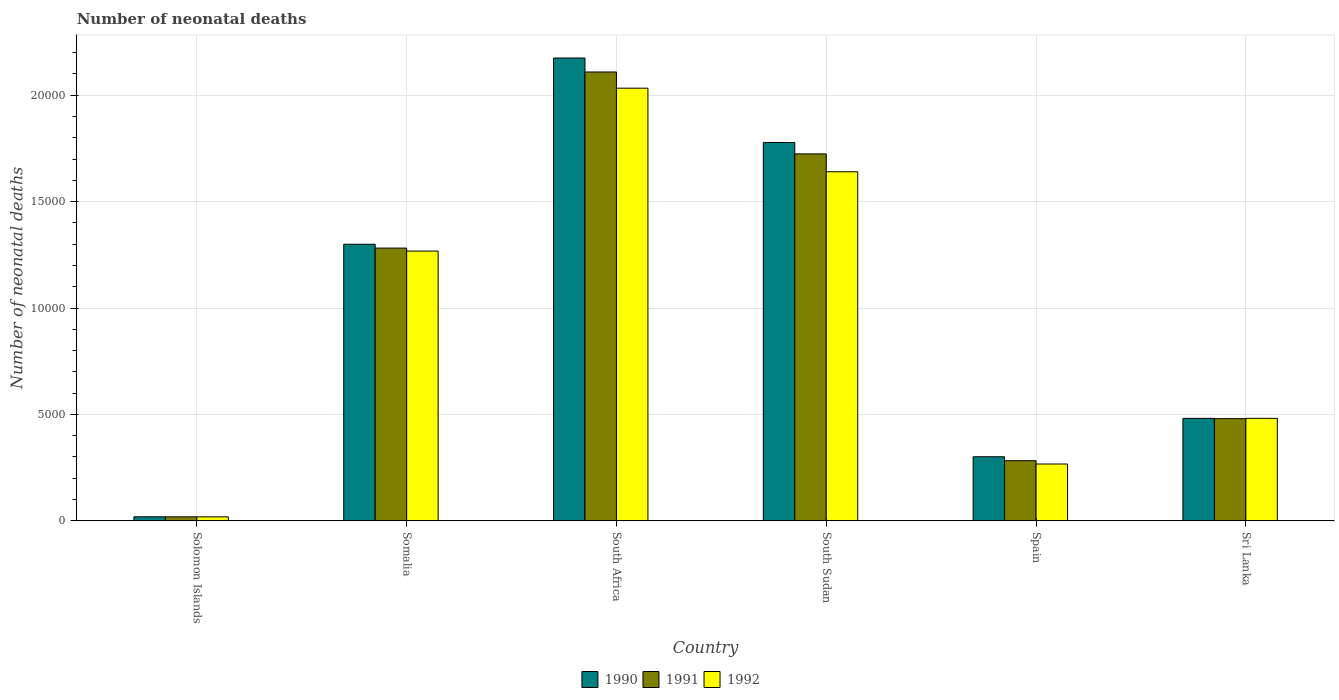How many different coloured bars are there?
Your answer should be very brief. 3. Are the number of bars per tick equal to the number of legend labels?
Ensure brevity in your answer.  Yes. What is the label of the 2nd group of bars from the left?
Provide a succinct answer. Somalia. What is the number of neonatal deaths in in 1990 in South Sudan?
Your response must be concise. 1.78e+04. Across all countries, what is the maximum number of neonatal deaths in in 1991?
Provide a succinct answer. 2.11e+04. Across all countries, what is the minimum number of neonatal deaths in in 1991?
Offer a terse response. 188. In which country was the number of neonatal deaths in in 1991 maximum?
Give a very brief answer. South Africa. In which country was the number of neonatal deaths in in 1992 minimum?
Ensure brevity in your answer.  Solomon Islands. What is the total number of neonatal deaths in in 1991 in the graph?
Provide a short and direct response. 5.90e+04. What is the difference between the number of neonatal deaths in in 1991 in South Africa and that in Spain?
Your answer should be compact. 1.83e+04. What is the difference between the number of neonatal deaths in in 1991 in Spain and the number of neonatal deaths in in 1990 in Somalia?
Offer a terse response. -1.02e+04. What is the average number of neonatal deaths in in 1991 per country?
Ensure brevity in your answer.  9826.5. What is the difference between the number of neonatal deaths in of/in 1992 and number of neonatal deaths in of/in 1990 in South Africa?
Provide a short and direct response. -1417. In how many countries, is the number of neonatal deaths in in 1991 greater than 3000?
Your response must be concise. 4. What is the ratio of the number of neonatal deaths in in 1990 in South Sudan to that in Spain?
Your response must be concise. 5.91. Is the number of neonatal deaths in in 1990 in Somalia less than that in South Sudan?
Your answer should be compact. Yes. What is the difference between the highest and the second highest number of neonatal deaths in in 1992?
Make the answer very short. 7654. What is the difference between the highest and the lowest number of neonatal deaths in in 1990?
Ensure brevity in your answer.  2.16e+04. In how many countries, is the number of neonatal deaths in in 1990 greater than the average number of neonatal deaths in in 1990 taken over all countries?
Keep it short and to the point. 3. Is the sum of the number of neonatal deaths in in 1992 in Solomon Islands and South Sudan greater than the maximum number of neonatal deaths in in 1991 across all countries?
Keep it short and to the point. No. Are all the bars in the graph horizontal?
Provide a succinct answer. No. Does the graph contain grids?
Provide a succinct answer. Yes. How are the legend labels stacked?
Give a very brief answer. Horizontal. What is the title of the graph?
Give a very brief answer. Number of neonatal deaths. What is the label or title of the X-axis?
Ensure brevity in your answer.  Country. What is the label or title of the Y-axis?
Keep it short and to the point. Number of neonatal deaths. What is the Number of neonatal deaths of 1990 in Solomon Islands?
Offer a terse response. 190. What is the Number of neonatal deaths of 1991 in Solomon Islands?
Offer a terse response. 188. What is the Number of neonatal deaths of 1992 in Solomon Islands?
Your answer should be very brief. 187. What is the Number of neonatal deaths of 1990 in Somalia?
Your answer should be compact. 1.30e+04. What is the Number of neonatal deaths of 1991 in Somalia?
Offer a terse response. 1.28e+04. What is the Number of neonatal deaths in 1992 in Somalia?
Make the answer very short. 1.27e+04. What is the Number of neonatal deaths in 1990 in South Africa?
Provide a succinct answer. 2.17e+04. What is the Number of neonatal deaths in 1991 in South Africa?
Provide a succinct answer. 2.11e+04. What is the Number of neonatal deaths in 1992 in South Africa?
Offer a very short reply. 2.03e+04. What is the Number of neonatal deaths in 1990 in South Sudan?
Ensure brevity in your answer.  1.78e+04. What is the Number of neonatal deaths of 1991 in South Sudan?
Ensure brevity in your answer.  1.72e+04. What is the Number of neonatal deaths of 1992 in South Sudan?
Ensure brevity in your answer.  1.64e+04. What is the Number of neonatal deaths in 1990 in Spain?
Your answer should be compact. 3010. What is the Number of neonatal deaths of 1991 in Spain?
Your answer should be compact. 2825. What is the Number of neonatal deaths in 1992 in Spain?
Offer a very short reply. 2670. What is the Number of neonatal deaths of 1990 in Sri Lanka?
Ensure brevity in your answer.  4814. What is the Number of neonatal deaths in 1991 in Sri Lanka?
Give a very brief answer. 4801. What is the Number of neonatal deaths in 1992 in Sri Lanka?
Your answer should be very brief. 4815. Across all countries, what is the maximum Number of neonatal deaths in 1990?
Offer a terse response. 2.17e+04. Across all countries, what is the maximum Number of neonatal deaths of 1991?
Give a very brief answer. 2.11e+04. Across all countries, what is the maximum Number of neonatal deaths of 1992?
Offer a terse response. 2.03e+04. Across all countries, what is the minimum Number of neonatal deaths of 1990?
Your response must be concise. 190. Across all countries, what is the minimum Number of neonatal deaths in 1991?
Keep it short and to the point. 188. Across all countries, what is the minimum Number of neonatal deaths in 1992?
Make the answer very short. 187. What is the total Number of neonatal deaths of 1990 in the graph?
Your answer should be compact. 6.05e+04. What is the total Number of neonatal deaths in 1991 in the graph?
Provide a succinct answer. 5.90e+04. What is the total Number of neonatal deaths of 1992 in the graph?
Keep it short and to the point. 5.71e+04. What is the difference between the Number of neonatal deaths of 1990 in Solomon Islands and that in Somalia?
Provide a succinct answer. -1.28e+04. What is the difference between the Number of neonatal deaths of 1991 in Solomon Islands and that in Somalia?
Provide a succinct answer. -1.26e+04. What is the difference between the Number of neonatal deaths of 1992 in Solomon Islands and that in Somalia?
Offer a terse response. -1.25e+04. What is the difference between the Number of neonatal deaths of 1990 in Solomon Islands and that in South Africa?
Offer a terse response. -2.16e+04. What is the difference between the Number of neonatal deaths of 1991 in Solomon Islands and that in South Africa?
Give a very brief answer. -2.09e+04. What is the difference between the Number of neonatal deaths in 1992 in Solomon Islands and that in South Africa?
Your answer should be very brief. -2.01e+04. What is the difference between the Number of neonatal deaths in 1990 in Solomon Islands and that in South Sudan?
Provide a short and direct response. -1.76e+04. What is the difference between the Number of neonatal deaths in 1991 in Solomon Islands and that in South Sudan?
Provide a short and direct response. -1.71e+04. What is the difference between the Number of neonatal deaths of 1992 in Solomon Islands and that in South Sudan?
Ensure brevity in your answer.  -1.62e+04. What is the difference between the Number of neonatal deaths in 1990 in Solomon Islands and that in Spain?
Provide a succinct answer. -2820. What is the difference between the Number of neonatal deaths of 1991 in Solomon Islands and that in Spain?
Your answer should be very brief. -2637. What is the difference between the Number of neonatal deaths of 1992 in Solomon Islands and that in Spain?
Offer a very short reply. -2483. What is the difference between the Number of neonatal deaths of 1990 in Solomon Islands and that in Sri Lanka?
Provide a succinct answer. -4624. What is the difference between the Number of neonatal deaths in 1991 in Solomon Islands and that in Sri Lanka?
Keep it short and to the point. -4613. What is the difference between the Number of neonatal deaths in 1992 in Solomon Islands and that in Sri Lanka?
Offer a very short reply. -4628. What is the difference between the Number of neonatal deaths of 1990 in Somalia and that in South Africa?
Offer a very short reply. -8751. What is the difference between the Number of neonatal deaths in 1991 in Somalia and that in South Africa?
Your answer should be very brief. -8274. What is the difference between the Number of neonatal deaths in 1992 in Somalia and that in South Africa?
Your answer should be very brief. -7654. What is the difference between the Number of neonatal deaths in 1990 in Somalia and that in South Sudan?
Provide a succinct answer. -4781. What is the difference between the Number of neonatal deaths of 1991 in Somalia and that in South Sudan?
Your answer should be very brief. -4426. What is the difference between the Number of neonatal deaths in 1992 in Somalia and that in South Sudan?
Your response must be concise. -3726. What is the difference between the Number of neonatal deaths in 1990 in Somalia and that in Spain?
Keep it short and to the point. 9985. What is the difference between the Number of neonatal deaths in 1991 in Somalia and that in Spain?
Your answer should be very brief. 9990. What is the difference between the Number of neonatal deaths of 1992 in Somalia and that in Spain?
Keep it short and to the point. 1.00e+04. What is the difference between the Number of neonatal deaths in 1990 in Somalia and that in Sri Lanka?
Offer a terse response. 8181. What is the difference between the Number of neonatal deaths of 1991 in Somalia and that in Sri Lanka?
Your answer should be compact. 8014. What is the difference between the Number of neonatal deaths in 1992 in Somalia and that in Sri Lanka?
Provide a short and direct response. 7860. What is the difference between the Number of neonatal deaths of 1990 in South Africa and that in South Sudan?
Give a very brief answer. 3970. What is the difference between the Number of neonatal deaths of 1991 in South Africa and that in South Sudan?
Ensure brevity in your answer.  3848. What is the difference between the Number of neonatal deaths of 1992 in South Africa and that in South Sudan?
Provide a short and direct response. 3928. What is the difference between the Number of neonatal deaths of 1990 in South Africa and that in Spain?
Your answer should be compact. 1.87e+04. What is the difference between the Number of neonatal deaths of 1991 in South Africa and that in Spain?
Give a very brief answer. 1.83e+04. What is the difference between the Number of neonatal deaths in 1992 in South Africa and that in Spain?
Provide a succinct answer. 1.77e+04. What is the difference between the Number of neonatal deaths of 1990 in South Africa and that in Sri Lanka?
Provide a succinct answer. 1.69e+04. What is the difference between the Number of neonatal deaths of 1991 in South Africa and that in Sri Lanka?
Make the answer very short. 1.63e+04. What is the difference between the Number of neonatal deaths in 1992 in South Africa and that in Sri Lanka?
Offer a terse response. 1.55e+04. What is the difference between the Number of neonatal deaths of 1990 in South Sudan and that in Spain?
Your answer should be compact. 1.48e+04. What is the difference between the Number of neonatal deaths of 1991 in South Sudan and that in Spain?
Give a very brief answer. 1.44e+04. What is the difference between the Number of neonatal deaths in 1992 in South Sudan and that in Spain?
Offer a terse response. 1.37e+04. What is the difference between the Number of neonatal deaths in 1990 in South Sudan and that in Sri Lanka?
Ensure brevity in your answer.  1.30e+04. What is the difference between the Number of neonatal deaths of 1991 in South Sudan and that in Sri Lanka?
Your answer should be compact. 1.24e+04. What is the difference between the Number of neonatal deaths in 1992 in South Sudan and that in Sri Lanka?
Provide a succinct answer. 1.16e+04. What is the difference between the Number of neonatal deaths of 1990 in Spain and that in Sri Lanka?
Your answer should be compact. -1804. What is the difference between the Number of neonatal deaths of 1991 in Spain and that in Sri Lanka?
Offer a terse response. -1976. What is the difference between the Number of neonatal deaths in 1992 in Spain and that in Sri Lanka?
Your answer should be very brief. -2145. What is the difference between the Number of neonatal deaths in 1990 in Solomon Islands and the Number of neonatal deaths in 1991 in Somalia?
Provide a short and direct response. -1.26e+04. What is the difference between the Number of neonatal deaths of 1990 in Solomon Islands and the Number of neonatal deaths of 1992 in Somalia?
Your answer should be very brief. -1.25e+04. What is the difference between the Number of neonatal deaths in 1991 in Solomon Islands and the Number of neonatal deaths in 1992 in Somalia?
Ensure brevity in your answer.  -1.25e+04. What is the difference between the Number of neonatal deaths of 1990 in Solomon Islands and the Number of neonatal deaths of 1991 in South Africa?
Ensure brevity in your answer.  -2.09e+04. What is the difference between the Number of neonatal deaths of 1990 in Solomon Islands and the Number of neonatal deaths of 1992 in South Africa?
Your answer should be compact. -2.01e+04. What is the difference between the Number of neonatal deaths of 1991 in Solomon Islands and the Number of neonatal deaths of 1992 in South Africa?
Make the answer very short. -2.01e+04. What is the difference between the Number of neonatal deaths in 1990 in Solomon Islands and the Number of neonatal deaths in 1991 in South Sudan?
Your answer should be compact. -1.71e+04. What is the difference between the Number of neonatal deaths of 1990 in Solomon Islands and the Number of neonatal deaths of 1992 in South Sudan?
Your answer should be very brief. -1.62e+04. What is the difference between the Number of neonatal deaths of 1991 in Solomon Islands and the Number of neonatal deaths of 1992 in South Sudan?
Your answer should be compact. -1.62e+04. What is the difference between the Number of neonatal deaths in 1990 in Solomon Islands and the Number of neonatal deaths in 1991 in Spain?
Provide a short and direct response. -2635. What is the difference between the Number of neonatal deaths in 1990 in Solomon Islands and the Number of neonatal deaths in 1992 in Spain?
Keep it short and to the point. -2480. What is the difference between the Number of neonatal deaths of 1991 in Solomon Islands and the Number of neonatal deaths of 1992 in Spain?
Offer a very short reply. -2482. What is the difference between the Number of neonatal deaths of 1990 in Solomon Islands and the Number of neonatal deaths of 1991 in Sri Lanka?
Provide a succinct answer. -4611. What is the difference between the Number of neonatal deaths in 1990 in Solomon Islands and the Number of neonatal deaths in 1992 in Sri Lanka?
Offer a very short reply. -4625. What is the difference between the Number of neonatal deaths in 1991 in Solomon Islands and the Number of neonatal deaths in 1992 in Sri Lanka?
Your answer should be compact. -4627. What is the difference between the Number of neonatal deaths in 1990 in Somalia and the Number of neonatal deaths in 1991 in South Africa?
Your answer should be very brief. -8094. What is the difference between the Number of neonatal deaths in 1990 in Somalia and the Number of neonatal deaths in 1992 in South Africa?
Keep it short and to the point. -7334. What is the difference between the Number of neonatal deaths in 1991 in Somalia and the Number of neonatal deaths in 1992 in South Africa?
Provide a short and direct response. -7514. What is the difference between the Number of neonatal deaths of 1990 in Somalia and the Number of neonatal deaths of 1991 in South Sudan?
Make the answer very short. -4246. What is the difference between the Number of neonatal deaths of 1990 in Somalia and the Number of neonatal deaths of 1992 in South Sudan?
Make the answer very short. -3406. What is the difference between the Number of neonatal deaths in 1991 in Somalia and the Number of neonatal deaths in 1992 in South Sudan?
Provide a succinct answer. -3586. What is the difference between the Number of neonatal deaths in 1990 in Somalia and the Number of neonatal deaths in 1991 in Spain?
Offer a terse response. 1.02e+04. What is the difference between the Number of neonatal deaths in 1990 in Somalia and the Number of neonatal deaths in 1992 in Spain?
Make the answer very short. 1.03e+04. What is the difference between the Number of neonatal deaths in 1991 in Somalia and the Number of neonatal deaths in 1992 in Spain?
Provide a short and direct response. 1.01e+04. What is the difference between the Number of neonatal deaths of 1990 in Somalia and the Number of neonatal deaths of 1991 in Sri Lanka?
Offer a terse response. 8194. What is the difference between the Number of neonatal deaths of 1990 in Somalia and the Number of neonatal deaths of 1992 in Sri Lanka?
Your response must be concise. 8180. What is the difference between the Number of neonatal deaths of 1991 in Somalia and the Number of neonatal deaths of 1992 in Sri Lanka?
Give a very brief answer. 8000. What is the difference between the Number of neonatal deaths of 1990 in South Africa and the Number of neonatal deaths of 1991 in South Sudan?
Ensure brevity in your answer.  4505. What is the difference between the Number of neonatal deaths in 1990 in South Africa and the Number of neonatal deaths in 1992 in South Sudan?
Provide a short and direct response. 5345. What is the difference between the Number of neonatal deaths of 1991 in South Africa and the Number of neonatal deaths of 1992 in South Sudan?
Give a very brief answer. 4688. What is the difference between the Number of neonatal deaths of 1990 in South Africa and the Number of neonatal deaths of 1991 in Spain?
Make the answer very short. 1.89e+04. What is the difference between the Number of neonatal deaths in 1990 in South Africa and the Number of neonatal deaths in 1992 in Spain?
Your answer should be very brief. 1.91e+04. What is the difference between the Number of neonatal deaths in 1991 in South Africa and the Number of neonatal deaths in 1992 in Spain?
Offer a terse response. 1.84e+04. What is the difference between the Number of neonatal deaths in 1990 in South Africa and the Number of neonatal deaths in 1991 in Sri Lanka?
Make the answer very short. 1.69e+04. What is the difference between the Number of neonatal deaths of 1990 in South Africa and the Number of neonatal deaths of 1992 in Sri Lanka?
Your response must be concise. 1.69e+04. What is the difference between the Number of neonatal deaths in 1991 in South Africa and the Number of neonatal deaths in 1992 in Sri Lanka?
Your response must be concise. 1.63e+04. What is the difference between the Number of neonatal deaths in 1990 in South Sudan and the Number of neonatal deaths in 1991 in Spain?
Keep it short and to the point. 1.50e+04. What is the difference between the Number of neonatal deaths of 1990 in South Sudan and the Number of neonatal deaths of 1992 in Spain?
Make the answer very short. 1.51e+04. What is the difference between the Number of neonatal deaths of 1991 in South Sudan and the Number of neonatal deaths of 1992 in Spain?
Make the answer very short. 1.46e+04. What is the difference between the Number of neonatal deaths in 1990 in South Sudan and the Number of neonatal deaths in 1991 in Sri Lanka?
Your answer should be very brief. 1.30e+04. What is the difference between the Number of neonatal deaths of 1990 in South Sudan and the Number of neonatal deaths of 1992 in Sri Lanka?
Offer a very short reply. 1.30e+04. What is the difference between the Number of neonatal deaths of 1991 in South Sudan and the Number of neonatal deaths of 1992 in Sri Lanka?
Give a very brief answer. 1.24e+04. What is the difference between the Number of neonatal deaths in 1990 in Spain and the Number of neonatal deaths in 1991 in Sri Lanka?
Make the answer very short. -1791. What is the difference between the Number of neonatal deaths of 1990 in Spain and the Number of neonatal deaths of 1992 in Sri Lanka?
Provide a short and direct response. -1805. What is the difference between the Number of neonatal deaths in 1991 in Spain and the Number of neonatal deaths in 1992 in Sri Lanka?
Offer a terse response. -1990. What is the average Number of neonatal deaths in 1990 per country?
Your answer should be compact. 1.01e+04. What is the average Number of neonatal deaths of 1991 per country?
Give a very brief answer. 9826.5. What is the average Number of neonatal deaths in 1992 per country?
Your answer should be very brief. 9512.83. What is the difference between the Number of neonatal deaths of 1990 and Number of neonatal deaths of 1991 in Solomon Islands?
Keep it short and to the point. 2. What is the difference between the Number of neonatal deaths of 1990 and Number of neonatal deaths of 1991 in Somalia?
Your answer should be compact. 180. What is the difference between the Number of neonatal deaths in 1990 and Number of neonatal deaths in 1992 in Somalia?
Make the answer very short. 320. What is the difference between the Number of neonatal deaths of 1991 and Number of neonatal deaths of 1992 in Somalia?
Provide a short and direct response. 140. What is the difference between the Number of neonatal deaths of 1990 and Number of neonatal deaths of 1991 in South Africa?
Provide a succinct answer. 657. What is the difference between the Number of neonatal deaths in 1990 and Number of neonatal deaths in 1992 in South Africa?
Your response must be concise. 1417. What is the difference between the Number of neonatal deaths of 1991 and Number of neonatal deaths of 1992 in South Africa?
Provide a succinct answer. 760. What is the difference between the Number of neonatal deaths in 1990 and Number of neonatal deaths in 1991 in South Sudan?
Make the answer very short. 535. What is the difference between the Number of neonatal deaths of 1990 and Number of neonatal deaths of 1992 in South Sudan?
Your answer should be very brief. 1375. What is the difference between the Number of neonatal deaths of 1991 and Number of neonatal deaths of 1992 in South Sudan?
Your response must be concise. 840. What is the difference between the Number of neonatal deaths in 1990 and Number of neonatal deaths in 1991 in Spain?
Give a very brief answer. 185. What is the difference between the Number of neonatal deaths in 1990 and Number of neonatal deaths in 1992 in Spain?
Provide a succinct answer. 340. What is the difference between the Number of neonatal deaths in 1991 and Number of neonatal deaths in 1992 in Spain?
Make the answer very short. 155. What is the difference between the Number of neonatal deaths of 1990 and Number of neonatal deaths of 1991 in Sri Lanka?
Make the answer very short. 13. What is the difference between the Number of neonatal deaths in 1990 and Number of neonatal deaths in 1992 in Sri Lanka?
Keep it short and to the point. -1. What is the difference between the Number of neonatal deaths of 1991 and Number of neonatal deaths of 1992 in Sri Lanka?
Make the answer very short. -14. What is the ratio of the Number of neonatal deaths in 1990 in Solomon Islands to that in Somalia?
Provide a succinct answer. 0.01. What is the ratio of the Number of neonatal deaths of 1991 in Solomon Islands to that in Somalia?
Ensure brevity in your answer.  0.01. What is the ratio of the Number of neonatal deaths of 1992 in Solomon Islands to that in Somalia?
Offer a terse response. 0.01. What is the ratio of the Number of neonatal deaths in 1990 in Solomon Islands to that in South Africa?
Ensure brevity in your answer.  0.01. What is the ratio of the Number of neonatal deaths in 1991 in Solomon Islands to that in South Africa?
Offer a terse response. 0.01. What is the ratio of the Number of neonatal deaths of 1992 in Solomon Islands to that in South Africa?
Provide a succinct answer. 0.01. What is the ratio of the Number of neonatal deaths of 1990 in Solomon Islands to that in South Sudan?
Offer a terse response. 0.01. What is the ratio of the Number of neonatal deaths in 1991 in Solomon Islands to that in South Sudan?
Keep it short and to the point. 0.01. What is the ratio of the Number of neonatal deaths of 1992 in Solomon Islands to that in South Sudan?
Offer a terse response. 0.01. What is the ratio of the Number of neonatal deaths in 1990 in Solomon Islands to that in Spain?
Your response must be concise. 0.06. What is the ratio of the Number of neonatal deaths in 1991 in Solomon Islands to that in Spain?
Offer a very short reply. 0.07. What is the ratio of the Number of neonatal deaths of 1992 in Solomon Islands to that in Spain?
Provide a succinct answer. 0.07. What is the ratio of the Number of neonatal deaths of 1990 in Solomon Islands to that in Sri Lanka?
Ensure brevity in your answer.  0.04. What is the ratio of the Number of neonatal deaths in 1991 in Solomon Islands to that in Sri Lanka?
Provide a short and direct response. 0.04. What is the ratio of the Number of neonatal deaths in 1992 in Solomon Islands to that in Sri Lanka?
Offer a very short reply. 0.04. What is the ratio of the Number of neonatal deaths of 1990 in Somalia to that in South Africa?
Offer a very short reply. 0.6. What is the ratio of the Number of neonatal deaths of 1991 in Somalia to that in South Africa?
Make the answer very short. 0.61. What is the ratio of the Number of neonatal deaths of 1992 in Somalia to that in South Africa?
Offer a terse response. 0.62. What is the ratio of the Number of neonatal deaths in 1990 in Somalia to that in South Sudan?
Offer a terse response. 0.73. What is the ratio of the Number of neonatal deaths in 1991 in Somalia to that in South Sudan?
Your answer should be compact. 0.74. What is the ratio of the Number of neonatal deaths of 1992 in Somalia to that in South Sudan?
Provide a succinct answer. 0.77. What is the ratio of the Number of neonatal deaths in 1990 in Somalia to that in Spain?
Keep it short and to the point. 4.32. What is the ratio of the Number of neonatal deaths in 1991 in Somalia to that in Spain?
Ensure brevity in your answer.  4.54. What is the ratio of the Number of neonatal deaths in 1992 in Somalia to that in Spain?
Your answer should be compact. 4.75. What is the ratio of the Number of neonatal deaths of 1990 in Somalia to that in Sri Lanka?
Provide a succinct answer. 2.7. What is the ratio of the Number of neonatal deaths in 1991 in Somalia to that in Sri Lanka?
Provide a short and direct response. 2.67. What is the ratio of the Number of neonatal deaths in 1992 in Somalia to that in Sri Lanka?
Make the answer very short. 2.63. What is the ratio of the Number of neonatal deaths of 1990 in South Africa to that in South Sudan?
Offer a terse response. 1.22. What is the ratio of the Number of neonatal deaths of 1991 in South Africa to that in South Sudan?
Offer a terse response. 1.22. What is the ratio of the Number of neonatal deaths in 1992 in South Africa to that in South Sudan?
Make the answer very short. 1.24. What is the ratio of the Number of neonatal deaths of 1990 in South Africa to that in Spain?
Provide a short and direct response. 7.22. What is the ratio of the Number of neonatal deaths of 1991 in South Africa to that in Spain?
Offer a terse response. 7.47. What is the ratio of the Number of neonatal deaths in 1992 in South Africa to that in Spain?
Your answer should be compact. 7.61. What is the ratio of the Number of neonatal deaths of 1990 in South Africa to that in Sri Lanka?
Keep it short and to the point. 4.52. What is the ratio of the Number of neonatal deaths of 1991 in South Africa to that in Sri Lanka?
Ensure brevity in your answer.  4.39. What is the ratio of the Number of neonatal deaths of 1992 in South Africa to that in Sri Lanka?
Ensure brevity in your answer.  4.22. What is the ratio of the Number of neonatal deaths in 1990 in South Sudan to that in Spain?
Give a very brief answer. 5.91. What is the ratio of the Number of neonatal deaths of 1991 in South Sudan to that in Spain?
Make the answer very short. 6.1. What is the ratio of the Number of neonatal deaths of 1992 in South Sudan to that in Spain?
Provide a succinct answer. 6.14. What is the ratio of the Number of neonatal deaths in 1990 in South Sudan to that in Sri Lanka?
Provide a succinct answer. 3.69. What is the ratio of the Number of neonatal deaths of 1991 in South Sudan to that in Sri Lanka?
Your response must be concise. 3.59. What is the ratio of the Number of neonatal deaths in 1992 in South Sudan to that in Sri Lanka?
Give a very brief answer. 3.41. What is the ratio of the Number of neonatal deaths of 1990 in Spain to that in Sri Lanka?
Provide a short and direct response. 0.63. What is the ratio of the Number of neonatal deaths in 1991 in Spain to that in Sri Lanka?
Your response must be concise. 0.59. What is the ratio of the Number of neonatal deaths in 1992 in Spain to that in Sri Lanka?
Offer a terse response. 0.55. What is the difference between the highest and the second highest Number of neonatal deaths in 1990?
Make the answer very short. 3970. What is the difference between the highest and the second highest Number of neonatal deaths of 1991?
Offer a very short reply. 3848. What is the difference between the highest and the second highest Number of neonatal deaths of 1992?
Provide a succinct answer. 3928. What is the difference between the highest and the lowest Number of neonatal deaths in 1990?
Ensure brevity in your answer.  2.16e+04. What is the difference between the highest and the lowest Number of neonatal deaths in 1991?
Your answer should be very brief. 2.09e+04. What is the difference between the highest and the lowest Number of neonatal deaths of 1992?
Your answer should be very brief. 2.01e+04. 